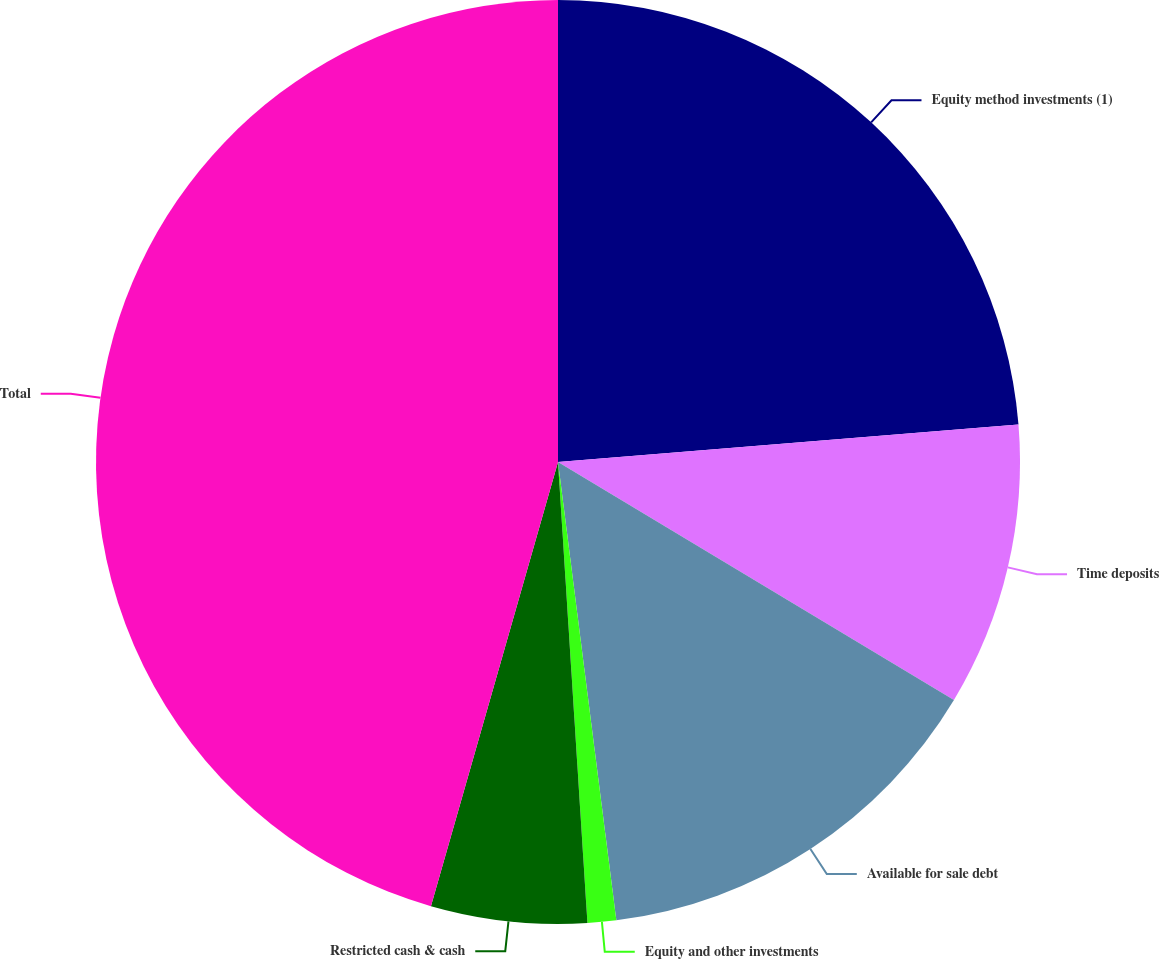Convert chart. <chart><loc_0><loc_0><loc_500><loc_500><pie_chart><fcel>Equity method investments (1)<fcel>Time deposits<fcel>Available for sale debt<fcel>Equity and other investments<fcel>Restricted cash & cash<fcel>Total<nl><fcel>23.71%<fcel>9.91%<fcel>14.37%<fcel>1.0%<fcel>5.45%<fcel>45.57%<nl></chart> 